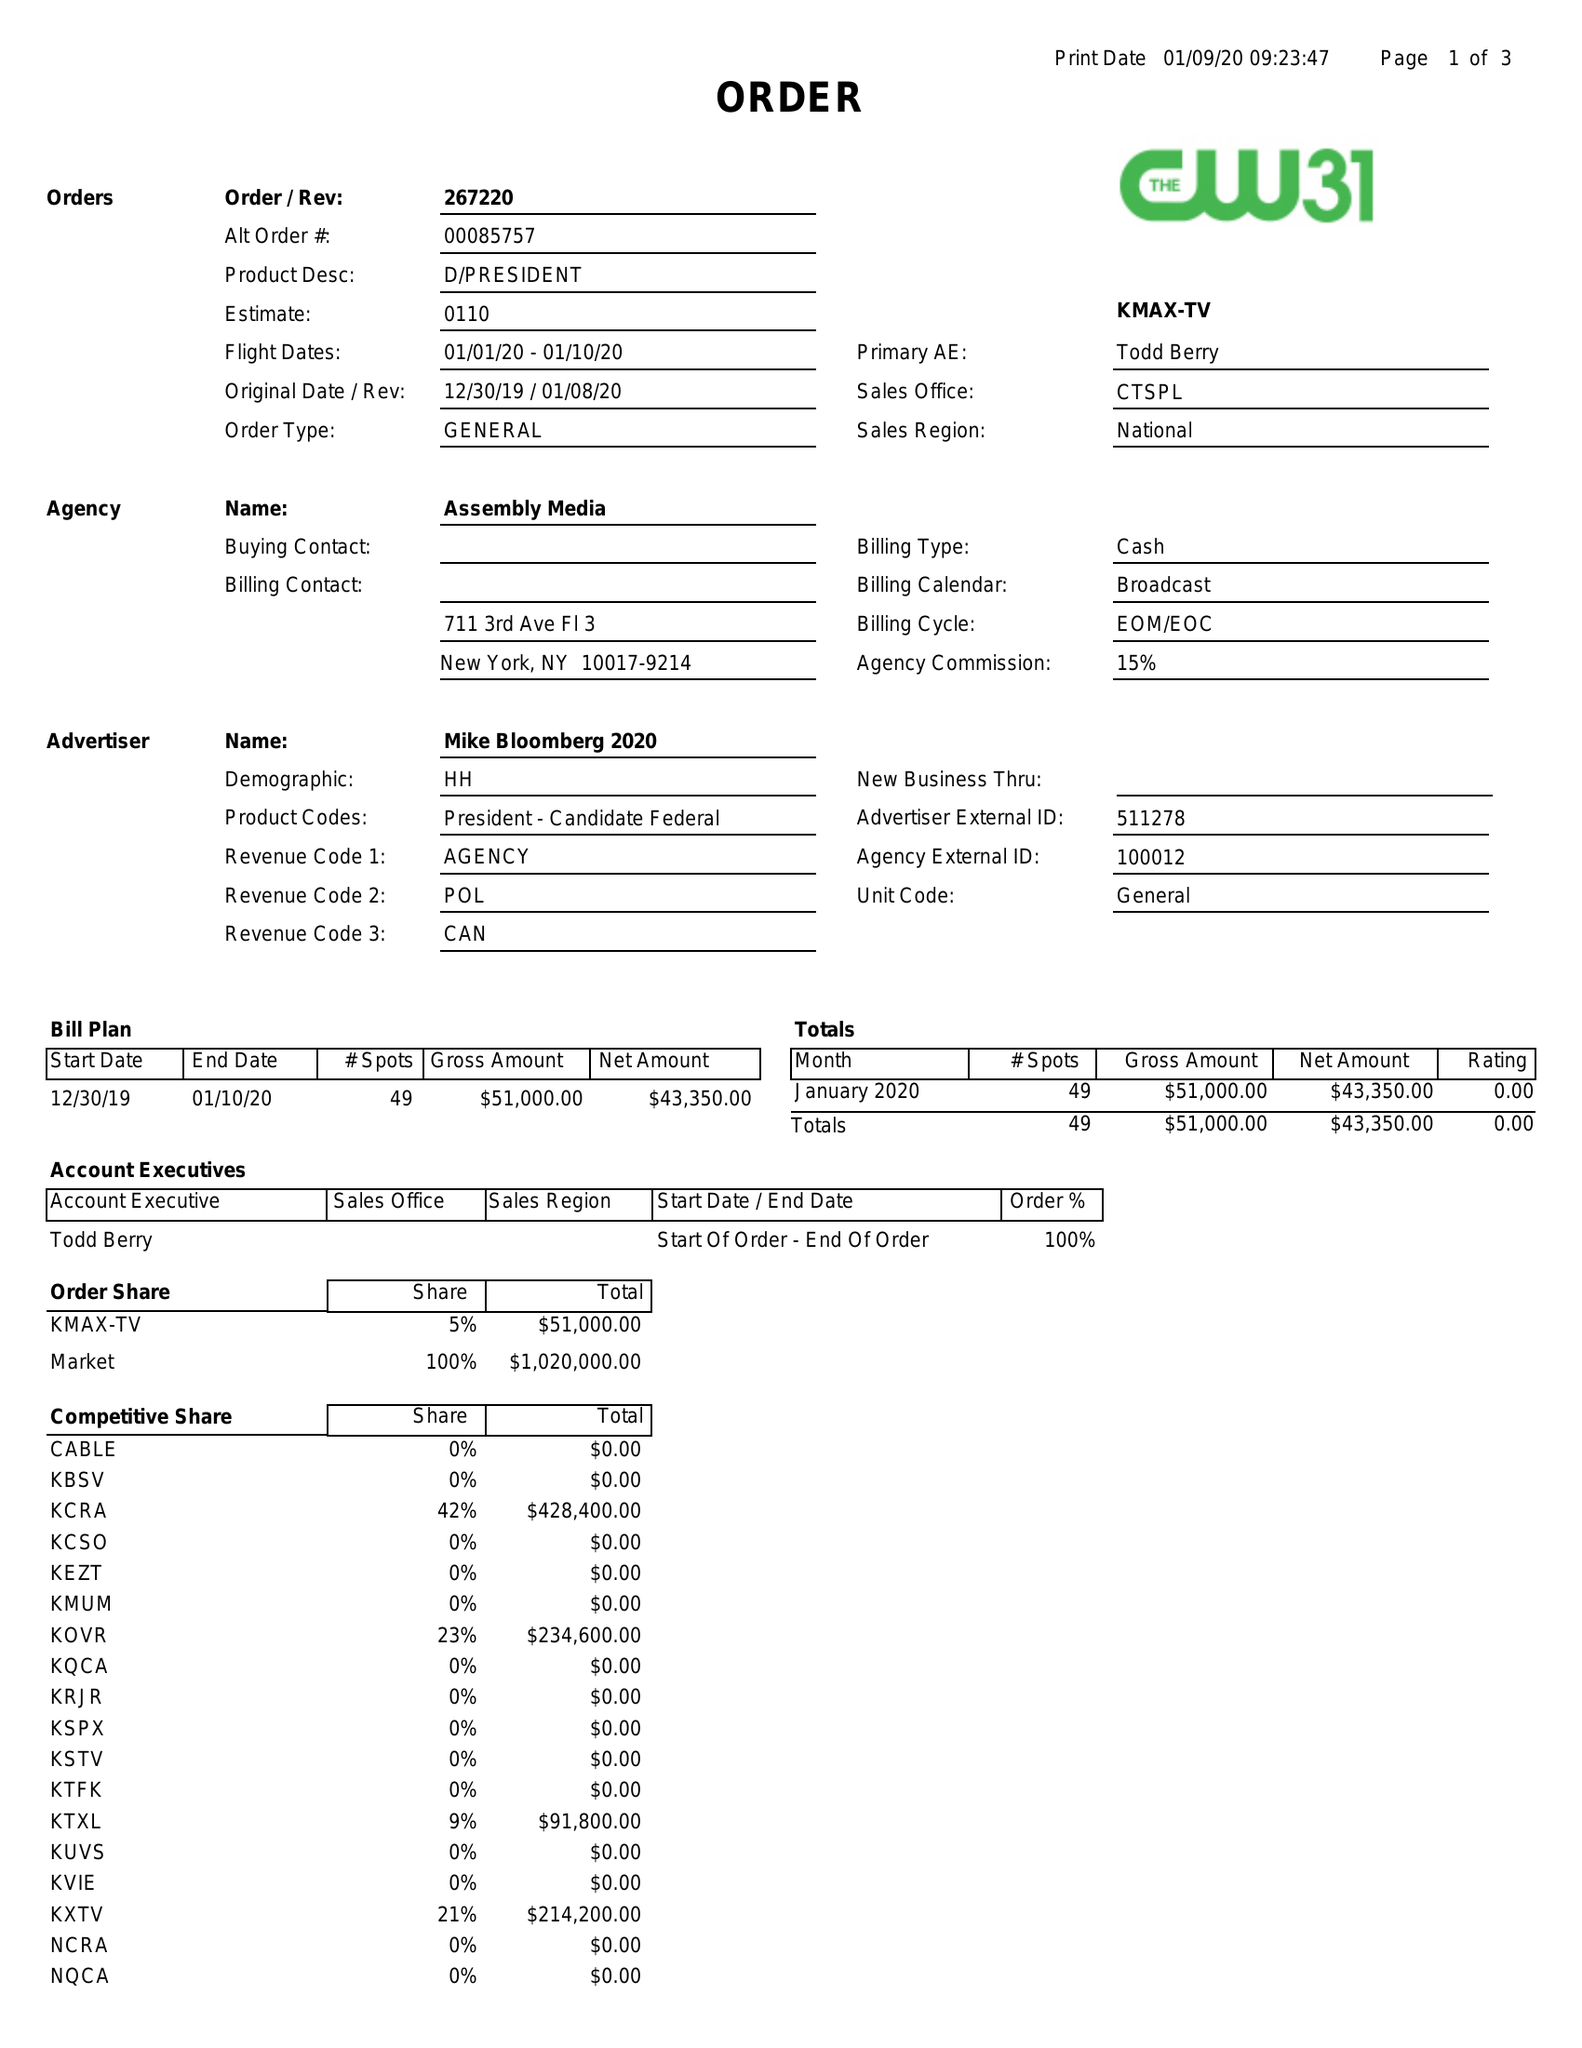What is the value for the advertiser?
Answer the question using a single word or phrase. MIKE BLOOMBERG 2020 